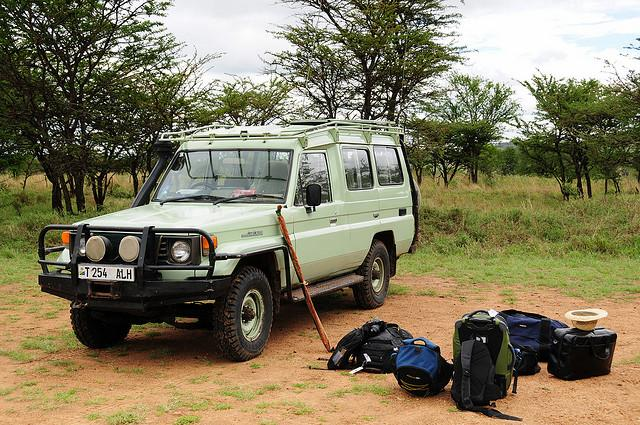What does the snorkel on the truck protect it from? Please explain your reasoning. water. It protects it from water. 